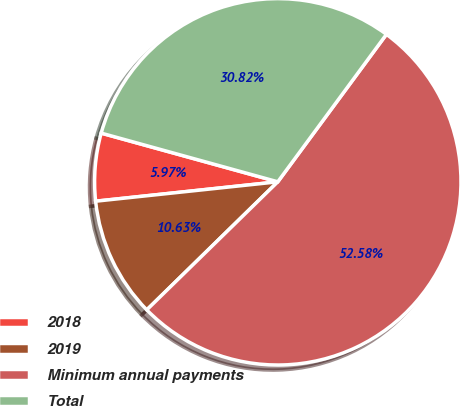Convert chart to OTSL. <chart><loc_0><loc_0><loc_500><loc_500><pie_chart><fcel>2018<fcel>2019<fcel>Minimum annual payments<fcel>Total<nl><fcel>5.97%<fcel>10.63%<fcel>52.57%<fcel>30.82%<nl></chart> 